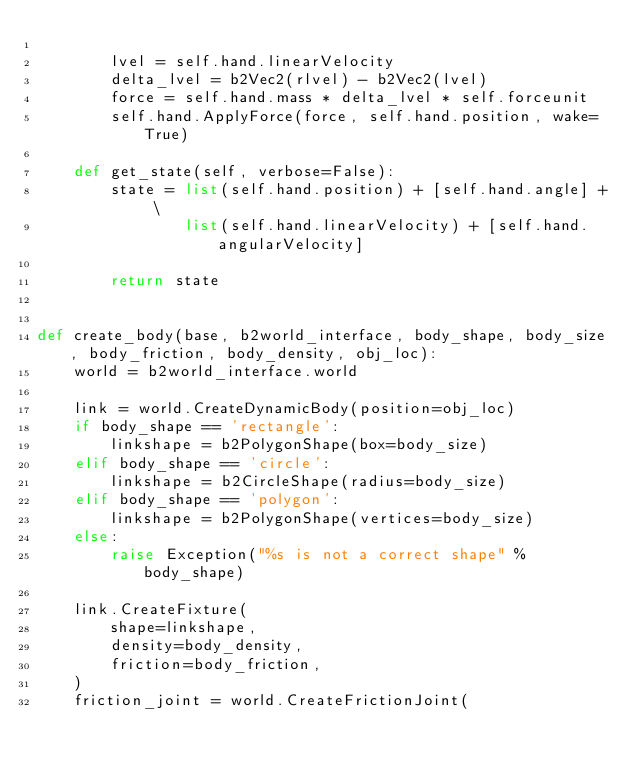Convert code to text. <code><loc_0><loc_0><loc_500><loc_500><_Python_>
        lvel = self.hand.linearVelocity
        delta_lvel = b2Vec2(rlvel) - b2Vec2(lvel)
        force = self.hand.mass * delta_lvel * self.forceunit
        self.hand.ApplyForce(force, self.hand.position, wake=True)

    def get_state(self, verbose=False):
        state = list(self.hand.position) + [self.hand.angle] + \
                list(self.hand.linearVelocity) + [self.hand.angularVelocity]

        return state


def create_body(base, b2world_interface, body_shape, body_size, body_friction, body_density, obj_loc):
    world = b2world_interface.world

    link = world.CreateDynamicBody(position=obj_loc)
    if body_shape == 'rectangle':
        linkshape = b2PolygonShape(box=body_size)
    elif body_shape == 'circle':
        linkshape = b2CircleShape(radius=body_size)
    elif body_shape == 'polygon':
        linkshape = b2PolygonShape(vertices=body_size)
    else:
        raise Exception("%s is not a correct shape" % body_shape)

    link.CreateFixture(
        shape=linkshape,
        density=body_density,
        friction=body_friction,
    )
    friction_joint = world.CreateFrictionJoint(</code> 